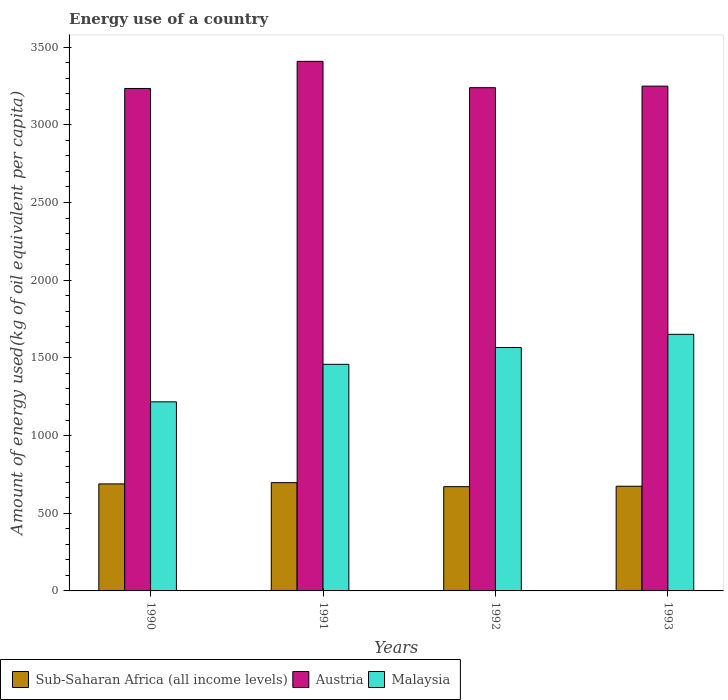How many different coloured bars are there?
Make the answer very short. 3. How many bars are there on the 3rd tick from the left?
Make the answer very short. 3. In how many cases, is the number of bars for a given year not equal to the number of legend labels?
Provide a succinct answer. 0. What is the amount of energy used in in Sub-Saharan Africa (all income levels) in 1993?
Make the answer very short. 673.9. Across all years, what is the maximum amount of energy used in in Austria?
Provide a short and direct response. 3408.51. Across all years, what is the minimum amount of energy used in in Malaysia?
Give a very brief answer. 1217.04. What is the total amount of energy used in in Sub-Saharan Africa (all income levels) in the graph?
Provide a short and direct response. 2730.57. What is the difference between the amount of energy used in in Malaysia in 1991 and that in 1993?
Ensure brevity in your answer.  -192.96. What is the difference between the amount of energy used in in Sub-Saharan Africa (all income levels) in 1992 and the amount of energy used in in Malaysia in 1990?
Give a very brief answer. -546.05. What is the average amount of energy used in in Austria per year?
Offer a very short reply. 3282.62. In the year 1991, what is the difference between the amount of energy used in in Malaysia and amount of energy used in in Austria?
Make the answer very short. -1950. What is the ratio of the amount of energy used in in Malaysia in 1990 to that in 1993?
Offer a terse response. 0.74. What is the difference between the highest and the second highest amount of energy used in in Sub-Saharan Africa (all income levels)?
Offer a very short reply. 8.11. What is the difference between the highest and the lowest amount of energy used in in Sub-Saharan Africa (all income levels)?
Ensure brevity in your answer.  25.9. What does the 3rd bar from the left in 1992 represents?
Offer a very short reply. Malaysia. What does the 1st bar from the right in 1990 represents?
Offer a very short reply. Malaysia. How many bars are there?
Keep it short and to the point. 12. Are all the bars in the graph horizontal?
Your answer should be very brief. No. How many years are there in the graph?
Give a very brief answer. 4. Are the values on the major ticks of Y-axis written in scientific E-notation?
Keep it short and to the point. No. Where does the legend appear in the graph?
Ensure brevity in your answer.  Bottom left. How are the legend labels stacked?
Your answer should be very brief. Horizontal. What is the title of the graph?
Your answer should be very brief. Energy use of a country. What is the label or title of the Y-axis?
Provide a succinct answer. Amount of energy used(kg of oil equivalent per capita). What is the Amount of energy used(kg of oil equivalent per capita) of Sub-Saharan Africa (all income levels) in 1990?
Offer a very short reply. 688.78. What is the Amount of energy used(kg of oil equivalent per capita) of Austria in 1990?
Give a very brief answer. 3233.95. What is the Amount of energy used(kg of oil equivalent per capita) in Malaysia in 1990?
Make the answer very short. 1217.04. What is the Amount of energy used(kg of oil equivalent per capita) of Sub-Saharan Africa (all income levels) in 1991?
Ensure brevity in your answer.  696.9. What is the Amount of energy used(kg of oil equivalent per capita) of Austria in 1991?
Provide a succinct answer. 3408.51. What is the Amount of energy used(kg of oil equivalent per capita) of Malaysia in 1991?
Make the answer very short. 1458.51. What is the Amount of energy used(kg of oil equivalent per capita) in Sub-Saharan Africa (all income levels) in 1992?
Your response must be concise. 670.99. What is the Amount of energy used(kg of oil equivalent per capita) of Austria in 1992?
Your answer should be compact. 3239.06. What is the Amount of energy used(kg of oil equivalent per capita) of Malaysia in 1992?
Provide a short and direct response. 1566.72. What is the Amount of energy used(kg of oil equivalent per capita) in Sub-Saharan Africa (all income levels) in 1993?
Your answer should be compact. 673.9. What is the Amount of energy used(kg of oil equivalent per capita) of Austria in 1993?
Make the answer very short. 3248.98. What is the Amount of energy used(kg of oil equivalent per capita) in Malaysia in 1993?
Ensure brevity in your answer.  1651.47. Across all years, what is the maximum Amount of energy used(kg of oil equivalent per capita) in Sub-Saharan Africa (all income levels)?
Provide a succinct answer. 696.9. Across all years, what is the maximum Amount of energy used(kg of oil equivalent per capita) of Austria?
Make the answer very short. 3408.51. Across all years, what is the maximum Amount of energy used(kg of oil equivalent per capita) of Malaysia?
Your response must be concise. 1651.47. Across all years, what is the minimum Amount of energy used(kg of oil equivalent per capita) in Sub-Saharan Africa (all income levels)?
Your answer should be very brief. 670.99. Across all years, what is the minimum Amount of energy used(kg of oil equivalent per capita) of Austria?
Make the answer very short. 3233.95. Across all years, what is the minimum Amount of energy used(kg of oil equivalent per capita) of Malaysia?
Your answer should be very brief. 1217.04. What is the total Amount of energy used(kg of oil equivalent per capita) of Sub-Saharan Africa (all income levels) in the graph?
Give a very brief answer. 2730.57. What is the total Amount of energy used(kg of oil equivalent per capita) of Austria in the graph?
Ensure brevity in your answer.  1.31e+04. What is the total Amount of energy used(kg of oil equivalent per capita) in Malaysia in the graph?
Offer a very short reply. 5893.75. What is the difference between the Amount of energy used(kg of oil equivalent per capita) in Sub-Saharan Africa (all income levels) in 1990 and that in 1991?
Your answer should be very brief. -8.11. What is the difference between the Amount of energy used(kg of oil equivalent per capita) of Austria in 1990 and that in 1991?
Make the answer very short. -174.56. What is the difference between the Amount of energy used(kg of oil equivalent per capita) in Malaysia in 1990 and that in 1991?
Provide a succinct answer. -241.47. What is the difference between the Amount of energy used(kg of oil equivalent per capita) of Sub-Saharan Africa (all income levels) in 1990 and that in 1992?
Provide a short and direct response. 17.79. What is the difference between the Amount of energy used(kg of oil equivalent per capita) of Austria in 1990 and that in 1992?
Your response must be concise. -5.12. What is the difference between the Amount of energy used(kg of oil equivalent per capita) of Malaysia in 1990 and that in 1992?
Make the answer very short. -349.68. What is the difference between the Amount of energy used(kg of oil equivalent per capita) of Sub-Saharan Africa (all income levels) in 1990 and that in 1993?
Your answer should be compact. 14.88. What is the difference between the Amount of energy used(kg of oil equivalent per capita) in Austria in 1990 and that in 1993?
Provide a short and direct response. -15.03. What is the difference between the Amount of energy used(kg of oil equivalent per capita) of Malaysia in 1990 and that in 1993?
Your answer should be very brief. -434.43. What is the difference between the Amount of energy used(kg of oil equivalent per capita) of Sub-Saharan Africa (all income levels) in 1991 and that in 1992?
Your response must be concise. 25.9. What is the difference between the Amount of energy used(kg of oil equivalent per capita) of Austria in 1991 and that in 1992?
Ensure brevity in your answer.  169.44. What is the difference between the Amount of energy used(kg of oil equivalent per capita) in Malaysia in 1991 and that in 1992?
Offer a terse response. -108.22. What is the difference between the Amount of energy used(kg of oil equivalent per capita) of Sub-Saharan Africa (all income levels) in 1991 and that in 1993?
Your response must be concise. 23. What is the difference between the Amount of energy used(kg of oil equivalent per capita) in Austria in 1991 and that in 1993?
Your answer should be compact. 159.52. What is the difference between the Amount of energy used(kg of oil equivalent per capita) in Malaysia in 1991 and that in 1993?
Your answer should be compact. -192.96. What is the difference between the Amount of energy used(kg of oil equivalent per capita) of Sub-Saharan Africa (all income levels) in 1992 and that in 1993?
Give a very brief answer. -2.91. What is the difference between the Amount of energy used(kg of oil equivalent per capita) in Austria in 1992 and that in 1993?
Give a very brief answer. -9.92. What is the difference between the Amount of energy used(kg of oil equivalent per capita) in Malaysia in 1992 and that in 1993?
Your response must be concise. -84.75. What is the difference between the Amount of energy used(kg of oil equivalent per capita) in Sub-Saharan Africa (all income levels) in 1990 and the Amount of energy used(kg of oil equivalent per capita) in Austria in 1991?
Provide a short and direct response. -2719.72. What is the difference between the Amount of energy used(kg of oil equivalent per capita) of Sub-Saharan Africa (all income levels) in 1990 and the Amount of energy used(kg of oil equivalent per capita) of Malaysia in 1991?
Your response must be concise. -769.73. What is the difference between the Amount of energy used(kg of oil equivalent per capita) of Austria in 1990 and the Amount of energy used(kg of oil equivalent per capita) of Malaysia in 1991?
Offer a very short reply. 1775.44. What is the difference between the Amount of energy used(kg of oil equivalent per capita) in Sub-Saharan Africa (all income levels) in 1990 and the Amount of energy used(kg of oil equivalent per capita) in Austria in 1992?
Keep it short and to the point. -2550.28. What is the difference between the Amount of energy used(kg of oil equivalent per capita) in Sub-Saharan Africa (all income levels) in 1990 and the Amount of energy used(kg of oil equivalent per capita) in Malaysia in 1992?
Provide a succinct answer. -877.94. What is the difference between the Amount of energy used(kg of oil equivalent per capita) in Austria in 1990 and the Amount of energy used(kg of oil equivalent per capita) in Malaysia in 1992?
Your response must be concise. 1667.22. What is the difference between the Amount of energy used(kg of oil equivalent per capita) in Sub-Saharan Africa (all income levels) in 1990 and the Amount of energy used(kg of oil equivalent per capita) in Austria in 1993?
Provide a short and direct response. -2560.2. What is the difference between the Amount of energy used(kg of oil equivalent per capita) of Sub-Saharan Africa (all income levels) in 1990 and the Amount of energy used(kg of oil equivalent per capita) of Malaysia in 1993?
Your answer should be compact. -962.69. What is the difference between the Amount of energy used(kg of oil equivalent per capita) in Austria in 1990 and the Amount of energy used(kg of oil equivalent per capita) in Malaysia in 1993?
Give a very brief answer. 1582.48. What is the difference between the Amount of energy used(kg of oil equivalent per capita) of Sub-Saharan Africa (all income levels) in 1991 and the Amount of energy used(kg of oil equivalent per capita) of Austria in 1992?
Make the answer very short. -2542.17. What is the difference between the Amount of energy used(kg of oil equivalent per capita) of Sub-Saharan Africa (all income levels) in 1991 and the Amount of energy used(kg of oil equivalent per capita) of Malaysia in 1992?
Give a very brief answer. -869.83. What is the difference between the Amount of energy used(kg of oil equivalent per capita) of Austria in 1991 and the Amount of energy used(kg of oil equivalent per capita) of Malaysia in 1992?
Your response must be concise. 1841.78. What is the difference between the Amount of energy used(kg of oil equivalent per capita) of Sub-Saharan Africa (all income levels) in 1991 and the Amount of energy used(kg of oil equivalent per capita) of Austria in 1993?
Your response must be concise. -2552.09. What is the difference between the Amount of energy used(kg of oil equivalent per capita) of Sub-Saharan Africa (all income levels) in 1991 and the Amount of energy used(kg of oil equivalent per capita) of Malaysia in 1993?
Your answer should be very brief. -954.58. What is the difference between the Amount of energy used(kg of oil equivalent per capita) of Austria in 1991 and the Amount of energy used(kg of oil equivalent per capita) of Malaysia in 1993?
Your answer should be very brief. 1757.03. What is the difference between the Amount of energy used(kg of oil equivalent per capita) in Sub-Saharan Africa (all income levels) in 1992 and the Amount of energy used(kg of oil equivalent per capita) in Austria in 1993?
Offer a terse response. -2577.99. What is the difference between the Amount of energy used(kg of oil equivalent per capita) in Sub-Saharan Africa (all income levels) in 1992 and the Amount of energy used(kg of oil equivalent per capita) in Malaysia in 1993?
Your answer should be very brief. -980.48. What is the difference between the Amount of energy used(kg of oil equivalent per capita) of Austria in 1992 and the Amount of energy used(kg of oil equivalent per capita) of Malaysia in 1993?
Provide a succinct answer. 1587.59. What is the average Amount of energy used(kg of oil equivalent per capita) of Sub-Saharan Africa (all income levels) per year?
Ensure brevity in your answer.  682.64. What is the average Amount of energy used(kg of oil equivalent per capita) in Austria per year?
Your answer should be compact. 3282.62. What is the average Amount of energy used(kg of oil equivalent per capita) of Malaysia per year?
Your answer should be compact. 1473.44. In the year 1990, what is the difference between the Amount of energy used(kg of oil equivalent per capita) of Sub-Saharan Africa (all income levels) and Amount of energy used(kg of oil equivalent per capita) of Austria?
Your answer should be very brief. -2545.17. In the year 1990, what is the difference between the Amount of energy used(kg of oil equivalent per capita) of Sub-Saharan Africa (all income levels) and Amount of energy used(kg of oil equivalent per capita) of Malaysia?
Your answer should be very brief. -528.26. In the year 1990, what is the difference between the Amount of energy used(kg of oil equivalent per capita) of Austria and Amount of energy used(kg of oil equivalent per capita) of Malaysia?
Your response must be concise. 2016.91. In the year 1991, what is the difference between the Amount of energy used(kg of oil equivalent per capita) of Sub-Saharan Africa (all income levels) and Amount of energy used(kg of oil equivalent per capita) of Austria?
Provide a succinct answer. -2711.61. In the year 1991, what is the difference between the Amount of energy used(kg of oil equivalent per capita) in Sub-Saharan Africa (all income levels) and Amount of energy used(kg of oil equivalent per capita) in Malaysia?
Your answer should be compact. -761.61. In the year 1991, what is the difference between the Amount of energy used(kg of oil equivalent per capita) in Austria and Amount of energy used(kg of oil equivalent per capita) in Malaysia?
Keep it short and to the point. 1950. In the year 1992, what is the difference between the Amount of energy used(kg of oil equivalent per capita) in Sub-Saharan Africa (all income levels) and Amount of energy used(kg of oil equivalent per capita) in Austria?
Offer a terse response. -2568.07. In the year 1992, what is the difference between the Amount of energy used(kg of oil equivalent per capita) in Sub-Saharan Africa (all income levels) and Amount of energy used(kg of oil equivalent per capita) in Malaysia?
Your response must be concise. -895.73. In the year 1992, what is the difference between the Amount of energy used(kg of oil equivalent per capita) of Austria and Amount of energy used(kg of oil equivalent per capita) of Malaysia?
Provide a short and direct response. 1672.34. In the year 1993, what is the difference between the Amount of energy used(kg of oil equivalent per capita) of Sub-Saharan Africa (all income levels) and Amount of energy used(kg of oil equivalent per capita) of Austria?
Offer a very short reply. -2575.08. In the year 1993, what is the difference between the Amount of energy used(kg of oil equivalent per capita) in Sub-Saharan Africa (all income levels) and Amount of energy used(kg of oil equivalent per capita) in Malaysia?
Make the answer very short. -977.57. In the year 1993, what is the difference between the Amount of energy used(kg of oil equivalent per capita) of Austria and Amount of energy used(kg of oil equivalent per capita) of Malaysia?
Your response must be concise. 1597.51. What is the ratio of the Amount of energy used(kg of oil equivalent per capita) in Sub-Saharan Africa (all income levels) in 1990 to that in 1991?
Provide a short and direct response. 0.99. What is the ratio of the Amount of energy used(kg of oil equivalent per capita) in Austria in 1990 to that in 1991?
Your answer should be very brief. 0.95. What is the ratio of the Amount of energy used(kg of oil equivalent per capita) of Malaysia in 1990 to that in 1991?
Your answer should be compact. 0.83. What is the ratio of the Amount of energy used(kg of oil equivalent per capita) in Sub-Saharan Africa (all income levels) in 1990 to that in 1992?
Your response must be concise. 1.03. What is the ratio of the Amount of energy used(kg of oil equivalent per capita) of Malaysia in 1990 to that in 1992?
Provide a short and direct response. 0.78. What is the ratio of the Amount of energy used(kg of oil equivalent per capita) of Sub-Saharan Africa (all income levels) in 1990 to that in 1993?
Your response must be concise. 1.02. What is the ratio of the Amount of energy used(kg of oil equivalent per capita) in Austria in 1990 to that in 1993?
Offer a terse response. 1. What is the ratio of the Amount of energy used(kg of oil equivalent per capita) of Malaysia in 1990 to that in 1993?
Offer a very short reply. 0.74. What is the ratio of the Amount of energy used(kg of oil equivalent per capita) of Sub-Saharan Africa (all income levels) in 1991 to that in 1992?
Keep it short and to the point. 1.04. What is the ratio of the Amount of energy used(kg of oil equivalent per capita) in Austria in 1991 to that in 1992?
Make the answer very short. 1.05. What is the ratio of the Amount of energy used(kg of oil equivalent per capita) of Malaysia in 1991 to that in 1992?
Give a very brief answer. 0.93. What is the ratio of the Amount of energy used(kg of oil equivalent per capita) of Sub-Saharan Africa (all income levels) in 1991 to that in 1993?
Your response must be concise. 1.03. What is the ratio of the Amount of energy used(kg of oil equivalent per capita) in Austria in 1991 to that in 1993?
Give a very brief answer. 1.05. What is the ratio of the Amount of energy used(kg of oil equivalent per capita) in Malaysia in 1991 to that in 1993?
Make the answer very short. 0.88. What is the ratio of the Amount of energy used(kg of oil equivalent per capita) of Austria in 1992 to that in 1993?
Provide a succinct answer. 1. What is the ratio of the Amount of energy used(kg of oil equivalent per capita) of Malaysia in 1992 to that in 1993?
Keep it short and to the point. 0.95. What is the difference between the highest and the second highest Amount of energy used(kg of oil equivalent per capita) of Sub-Saharan Africa (all income levels)?
Provide a short and direct response. 8.11. What is the difference between the highest and the second highest Amount of energy used(kg of oil equivalent per capita) in Austria?
Offer a very short reply. 159.52. What is the difference between the highest and the second highest Amount of energy used(kg of oil equivalent per capita) in Malaysia?
Ensure brevity in your answer.  84.75. What is the difference between the highest and the lowest Amount of energy used(kg of oil equivalent per capita) of Sub-Saharan Africa (all income levels)?
Your answer should be very brief. 25.9. What is the difference between the highest and the lowest Amount of energy used(kg of oil equivalent per capita) of Austria?
Provide a succinct answer. 174.56. What is the difference between the highest and the lowest Amount of energy used(kg of oil equivalent per capita) in Malaysia?
Make the answer very short. 434.43. 